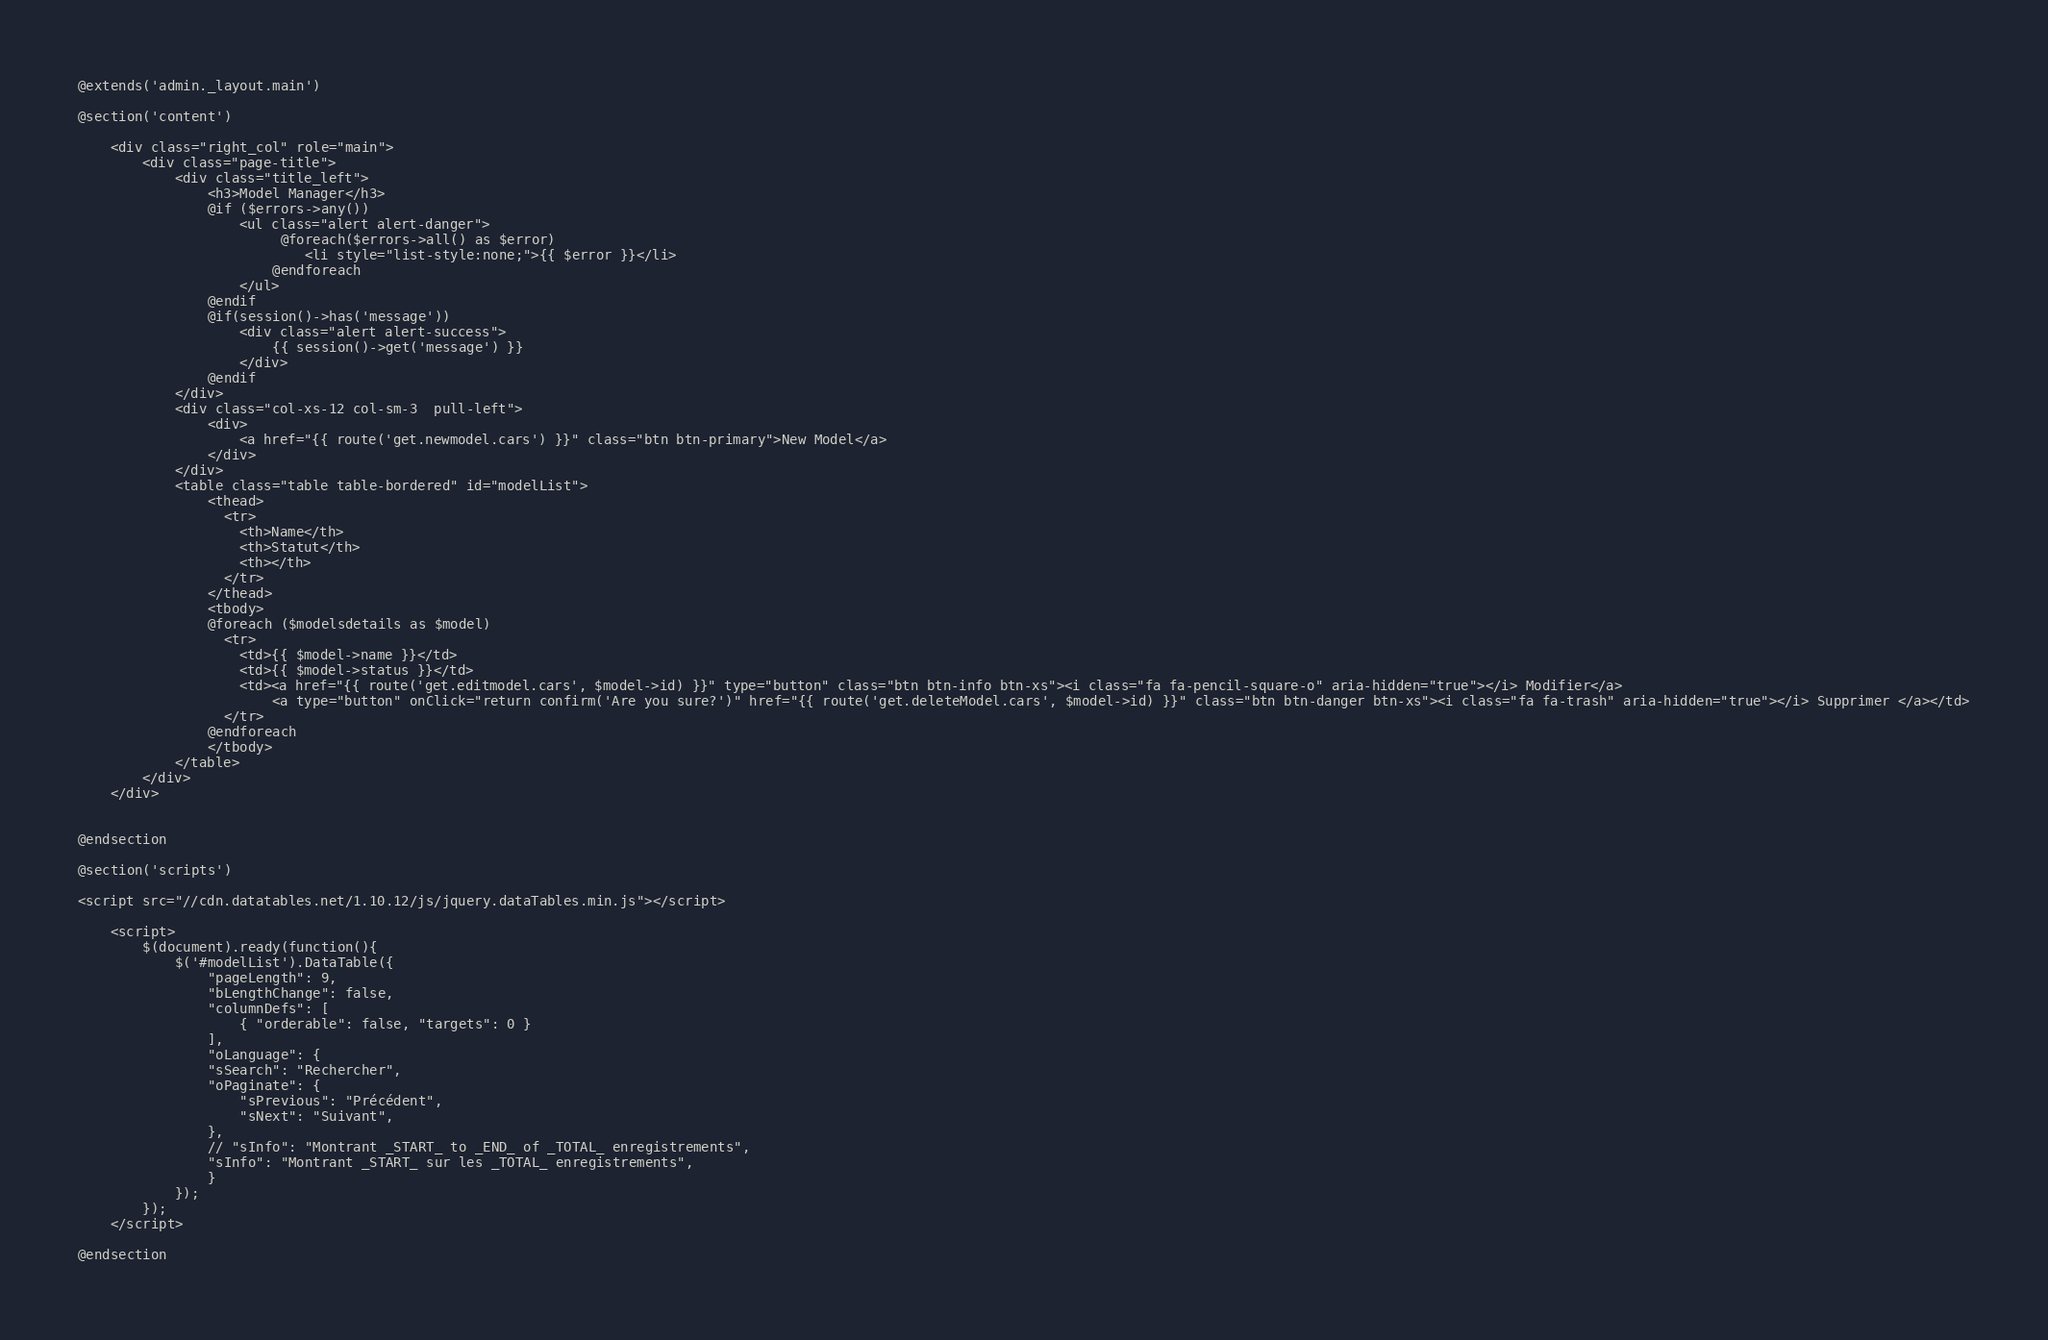Convert code to text. <code><loc_0><loc_0><loc_500><loc_500><_PHP_>@extends('admin._layout.main')

@section('content')

	<div class="right_col" role="main">
        <div class="page-title">
            <div class="title_left">
                <h3>Model Manager</h3>
                @if ($errors->any())
					<ul class="alert alert-danger">
					     @foreach($errors->all() as $error)
					        <li style="list-style:none;">{{ $error }}</li>
					    @endforeach
					</ul>
				@endif
				@if(session()->has('message'))
				    <div class="alert alert-success">
				        {{ session()->get('message') }}
				    </div>
				@endif
            </div>
            <div class="col-xs-12 col-sm-3  pull-left">
                <div>
                    <a href="{{ route('get.newmodel.cars') }}" class="btn btn-primary">New Model</a>
                </div>
            </div>
	        <table class="table table-bordered" id="modelList">
			    <thead>
			      <tr>
			        <th>Name</th>
			        <th>Statut</th>
			        <th></th>
			      </tr>
			    </thead>
			    <tbody>
			    @foreach ($modelsdetails as $model)
			      <tr>
			        <td>{{ $model->name }}</td>
			        <td>{{ $model->status }}</td>
			        <td><a href="{{ route('get.editmodel.cars', $model->id) }}" type="button" class="btn btn-info btn-xs"><i class="fa fa-pencil-square-o" aria-hidden="true"></i> Modifier</a>
                        <a type="button" onClick="return confirm('Are you sure?')" href="{{ route('get.deleteModel.cars', $model->id) }}" class="btn btn-danger btn-xs"><i class="fa fa-trash" aria-hidden="true"></i> Supprimer </a></td>
			      </tr>
			    @endforeach  
			    </tbody>
		    </table>
		</div>    
	</div>		                
              

@endsection

@section('scripts')

<script src="//cdn.datatables.net/1.10.12/js/jquery.dataTables.min.js"></script>

    <script>
        $(document).ready(function(){
            $('#modelList').DataTable({
                "pageLength": 9,
                "bLengthChange": false,
                "columnDefs": [
                    { "orderable": false, "targets": 0 }
                ],
                "oLanguage": {
                "sSearch": "Rechercher",
                "oPaginate": {
                    "sPrevious": "Précédent",
                    "sNext": "Suivant",
                },
                // "sInfo": "Montrant _START_ to _END_ of _TOTAL_ enregistrements",
                "sInfo": "Montrant _START_ sur les _TOTAL_ enregistrements",
            	}
            });
        });
    </script>

@endsection </code> 